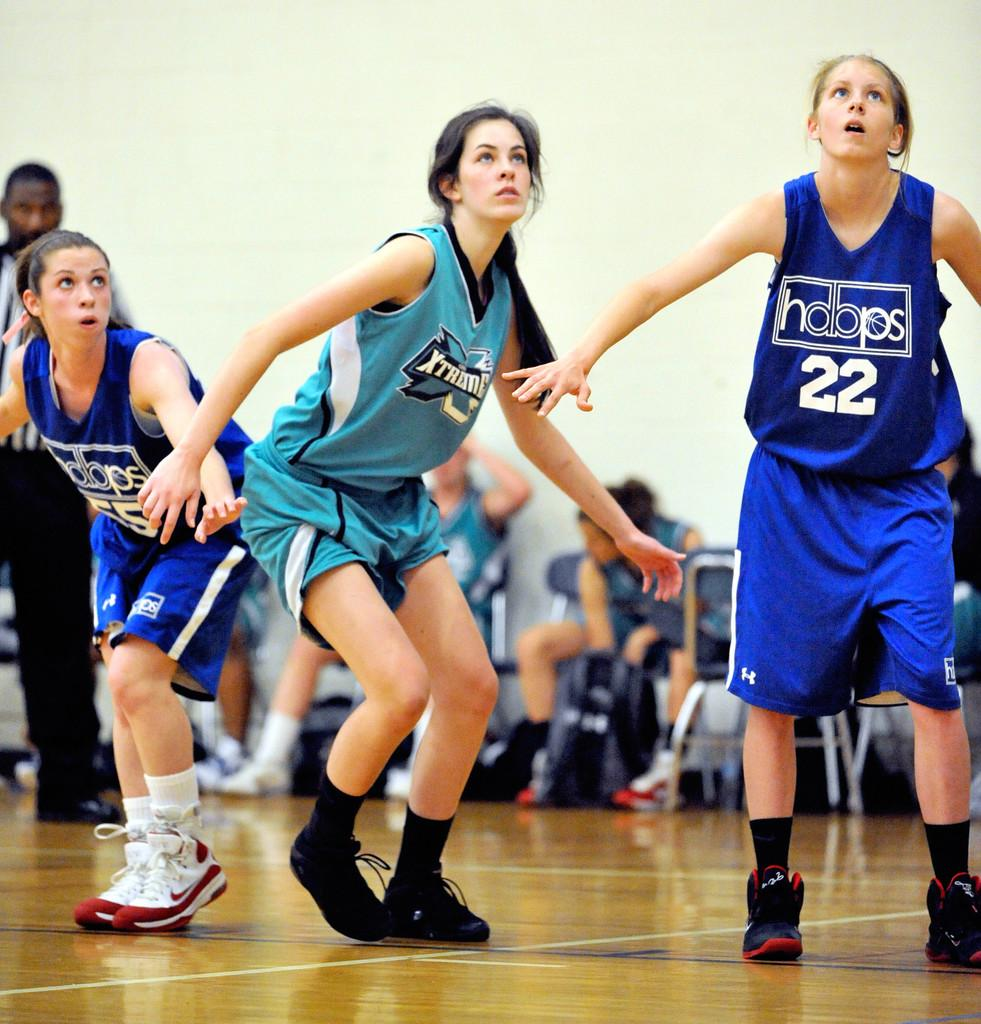Provide a one-sentence caption for the provided image. A team of female players wear uniforms for hdbps. 